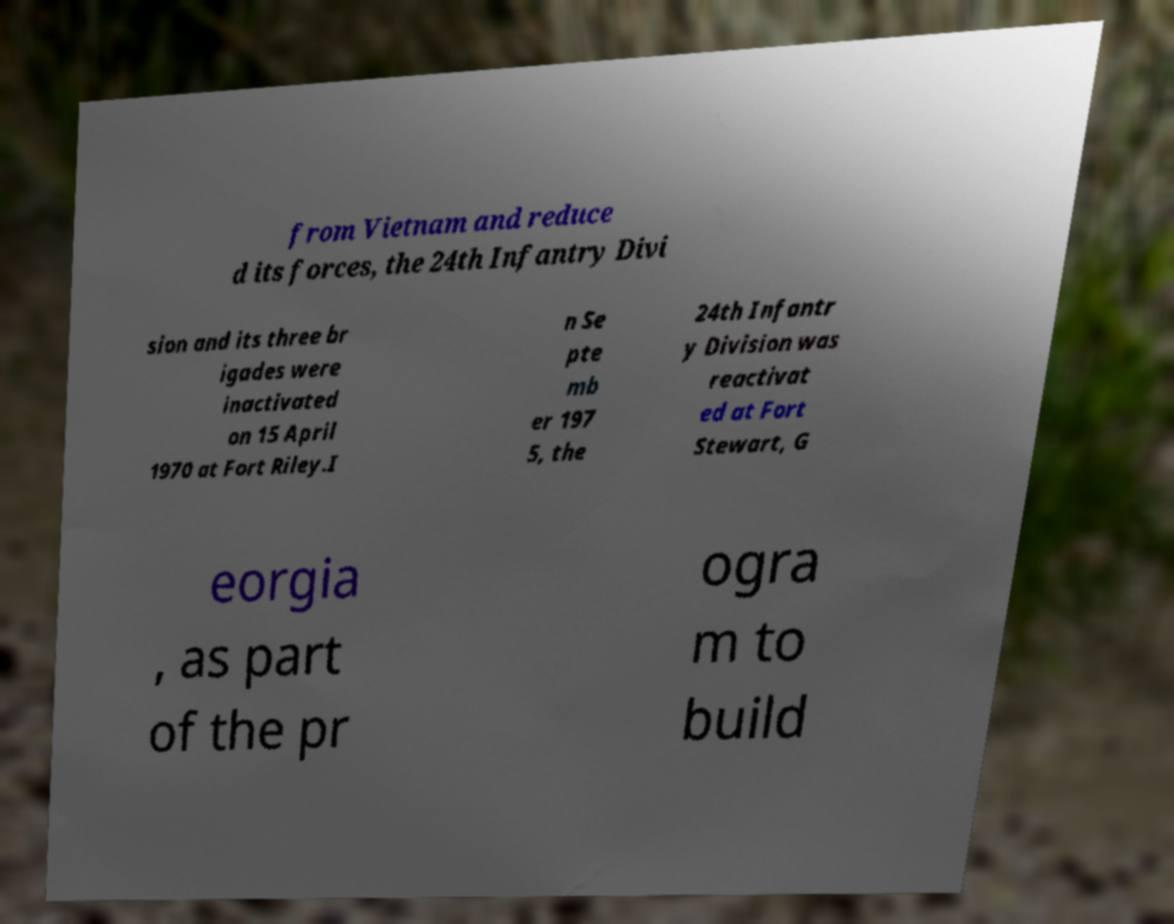There's text embedded in this image that I need extracted. Can you transcribe it verbatim? from Vietnam and reduce d its forces, the 24th Infantry Divi sion and its three br igades were inactivated on 15 April 1970 at Fort Riley.I n Se pte mb er 197 5, the 24th Infantr y Division was reactivat ed at Fort Stewart, G eorgia , as part of the pr ogra m to build 